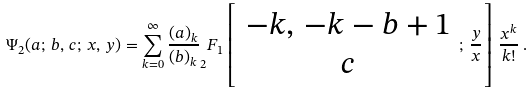Convert formula to latex. <formula><loc_0><loc_0><loc_500><loc_500>\Psi _ { 2 } ( a ; \, b , \, c ; \, x , \, y ) = \sum _ { k = 0 } ^ { \infty } \frac { ( a ) _ { k } } { ( b ) _ { k } } _ { 2 } F _ { 1 } \left [ \begin{array} { c } - k , \, - k - b + 1 \\ c \end{array} ; \, \frac { y } { x } \right ] \, \frac { x ^ { k } } { k ! } \, .</formula> 